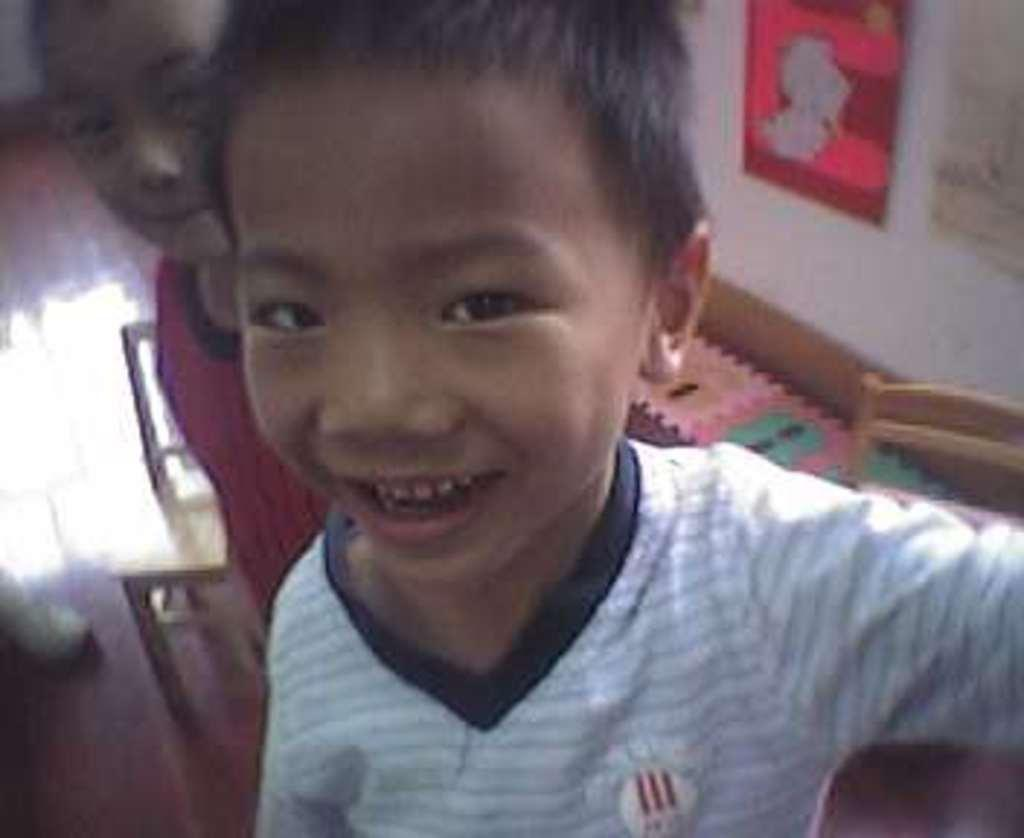What are the people in the image wearing? The people in the image are wearing different color dresses. Can you describe any objects visible in the image? Unfortunately, the provided facts do not mention any specific objects in the image. What is the background of the image? There is a wall in the image, which serves as the background. What is the reaction of the daughter when she sees the surprise in the image? There is no daughter or surprise present in the image, so this question cannot be answered. 